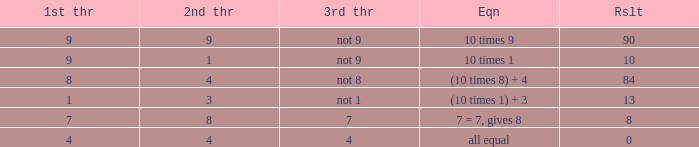If the equation is (10 times 1) + 3, what is the 2nd throw? 3.0. 